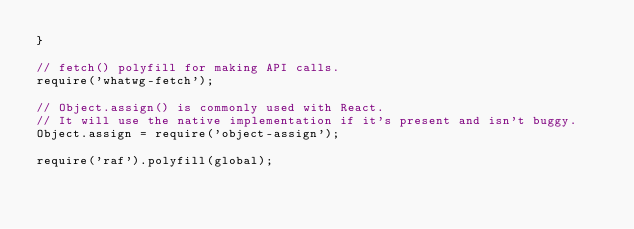Convert code to text. <code><loc_0><loc_0><loc_500><loc_500><_JavaScript_>}

// fetch() polyfill for making API calls.
require('whatwg-fetch');

// Object.assign() is commonly used with React.
// It will use the native implementation if it's present and isn't buggy.
Object.assign = require('object-assign');

require('raf').polyfill(global);
</code> 